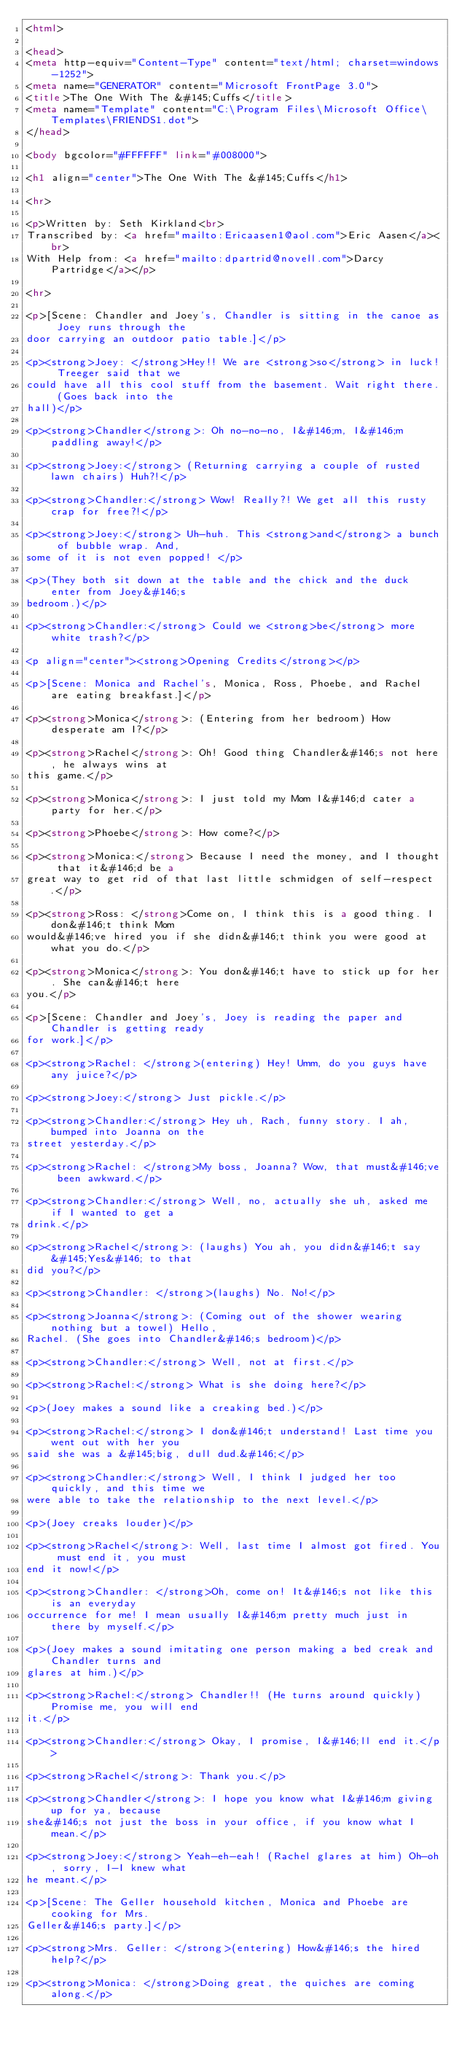<code> <loc_0><loc_0><loc_500><loc_500><_HTML_><html>

<head>
<meta http-equiv="Content-Type" content="text/html; charset=windows-1252">
<meta name="GENERATOR" content="Microsoft FrontPage 3.0">
<title>The One With The &#145;Cuffs</title>
<meta name="Template" content="C:\Program Files\Microsoft Office\Templates\FRIENDS1.dot">
</head>

<body bgcolor="#FFFFFF" link="#008000">

<h1 align="center">The One With The &#145;Cuffs</h1>

<hr>

<p>Written by: Seth Kirkland<br>
Transcribed by: <a href="mailto:Ericaasen1@aol.com">Eric Aasen</a><br>
With Help from: <a href="mailto:dpartrid@novell.com">Darcy Partridge</a></p>

<hr>

<p>[Scene: Chandler and Joey's, Chandler is sitting in the canoe as Joey runs through the
door carrying an outdoor patio table.]</p>

<p><strong>Joey: </strong>Hey!! We are <strong>so</strong> in luck! Treeger said that we
could have all this cool stuff from the basement. Wait right there. (Goes back into the
hall)</p>

<p><strong>Chandler</strong>: Oh no-no-no, I&#146;m, I&#146;m paddling away!</p>

<p><strong>Joey:</strong> (Returning carrying a couple of rusted lawn chairs) Huh?!</p>

<p><strong>Chandler:</strong> Wow! Really?! We get all this rusty crap for free?!</p>

<p><strong>Joey:</strong> Uh-huh. This <strong>and</strong> a bunch of bubble wrap. And,
some of it is not even popped! </p>

<p>(They both sit down at the table and the chick and the duck enter from Joey&#146;s
bedroom.)</p>

<p><strong>Chandler:</strong> Could we <strong>be</strong> more white trash?</p>

<p align="center"><strong>Opening Credits</strong></p>

<p>[Scene: Monica and Rachel's, Monica, Ross, Phoebe, and Rachel are eating breakfast.]</p>

<p><strong>Monica</strong>: (Entering from her bedroom) How desperate am I?</p>

<p><strong>Rachel</strong>: Oh! Good thing Chandler&#146;s not here, he always wins at
this game.</p>

<p><strong>Monica</strong>: I just told my Mom I&#146;d cater a party for her.</p>

<p><strong>Phoebe</strong>: How come?</p>

<p><strong>Monica:</strong> Because I need the money, and I thought that it&#146;d be a
great way to get rid of that last little schmidgen of self-respect.</p>

<p><strong>Ross: </strong>Come on, I think this is a good thing. I don&#146;t think Mom
would&#146;ve hired you if she didn&#146;t think you were good at what you do.</p>

<p><strong>Monica</strong>: You don&#146;t have to stick up for her. She can&#146;t here
you.</p>

<p>[Scene: Chandler and Joey's, Joey is reading the paper and Chandler is getting ready
for work.]</p>

<p><strong>Rachel: </strong>(entering) Hey! Umm, do you guys have any juice?</p>

<p><strong>Joey:</strong> Just pickle.</p>

<p><strong>Chandler:</strong> Hey uh, Rach, funny story. I ah, bumped into Joanna on the
street yesterday.</p>

<p><strong>Rachel: </strong>My boss, Joanna? Wow, that must&#146;ve been awkward.</p>

<p><strong>Chandler:</strong> Well, no, actually she uh, asked me if I wanted to get a
drink.</p>

<p><strong>Rachel</strong>: (laughs) You ah, you didn&#146;t say &#145;Yes&#146; to that
did you?</p>

<p><strong>Chandler: </strong>(laughs) No. No!</p>

<p><strong>Joanna</strong>: (Coming out of the shower wearing nothing but a towel) Hello,
Rachel. (She goes into Chandler&#146;s bedroom)</p>

<p><strong>Chandler:</strong> Well, not at first.</p>

<p><strong>Rachel:</strong> What is she doing here?</p>

<p>(Joey makes a sound like a creaking bed.)</p>

<p><strong>Rachel:</strong> I don&#146;t understand! Last time you went out with her you
said she was a &#145;big, dull dud.&#146;</p>

<p><strong>Chandler:</strong> Well, I think I judged her too quickly, and this time we
were able to take the relationship to the next level.</p>

<p>(Joey creaks louder)</p>

<p><strong>Rachel</strong>: Well, last time I almost got fired. You must end it, you must
end it now!</p>

<p><strong>Chandler: </strong>Oh, come on! It&#146;s not like this is an everyday
occurrence for me! I mean usually I&#146;m pretty much just in there by myself.</p>

<p>(Joey makes a sound imitating one person making a bed creak and Chandler turns and
glares at him.)</p>

<p><strong>Rachel:</strong> Chandler!! (He turns around quickly) Promise me, you will end
it.</p>

<p><strong>Chandler:</strong> Okay, I promise, I&#146;ll end it.</p>

<p><strong>Rachel</strong>: Thank you.</p>

<p><strong>Chandler</strong>: I hope you know what I&#146;m giving up for ya, because
she&#146;s not just the boss in your office, if you know what I mean.</p>

<p><strong>Joey:</strong> Yeah-eh-eah! (Rachel glares at him) Oh-oh, sorry, I-I knew what
he meant.</p>

<p>[Scene: The Geller household kitchen, Monica and Phoebe are cooking for Mrs.
Geller&#146;s party.]</p>

<p><strong>Mrs. Geller: </strong>(entering) How&#146;s the hired help?</p>

<p><strong>Monica: </strong>Doing great, the quiches are coming along.</p>
</code> 